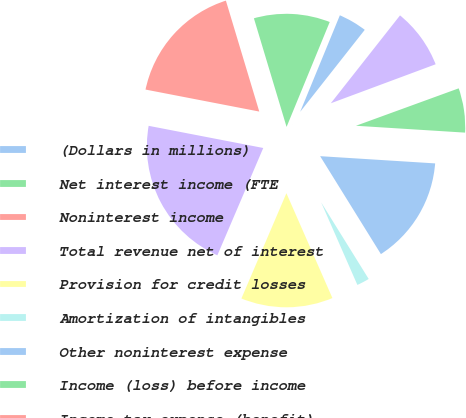<chart> <loc_0><loc_0><loc_500><loc_500><pie_chart><fcel>(Dollars in millions)<fcel>Net interest income (FTE<fcel>Noninterest income<fcel>Total revenue net of interest<fcel>Provision for credit losses<fcel>Amortization of intangibles<fcel>Other noninterest expense<fcel>Income (loss) before income<fcel>Income tax expense (benefit)<fcel>Net income (loss)<nl><fcel>4.41%<fcel>10.86%<fcel>17.31%<fcel>21.61%<fcel>13.01%<fcel>2.26%<fcel>15.16%<fcel>6.56%<fcel>0.11%<fcel>8.71%<nl></chart> 